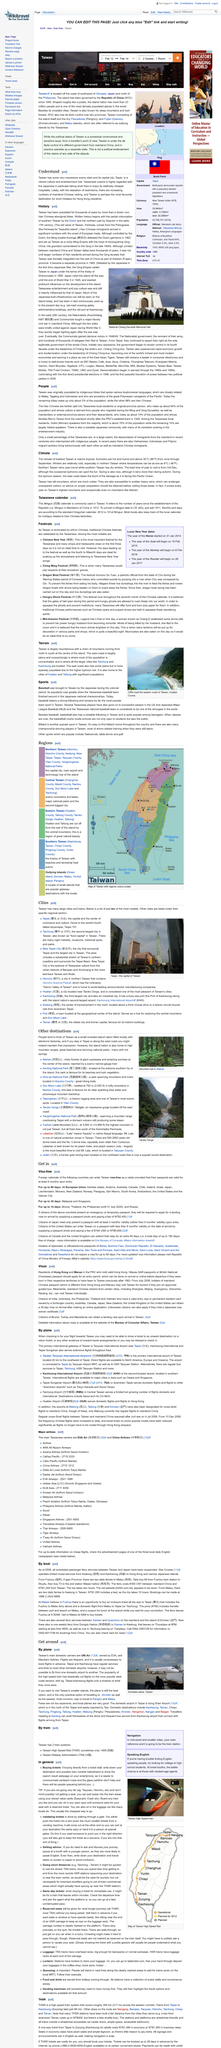Point out several critical features in this image. UNI Air is Taiwan's primary domestic airline, serving a significant portion of the country's air travel demand. Individuals from mainland China, including those from cities such as Shanghai and Beijing, are permitted to visit Taiwan. Yes, Japanese nationals can enter Taiwan visa-free for a period of up to 90 days as a visitor, provided that their passports are valid for at least 6 months upon entry. Yes, there are boat services available that operate from both Kaohsiung and Fuzhou. Taiwan is predominantly inhabited by ethnic Chinese people, who exert a significant influence on the island's culture, politics, and society. 